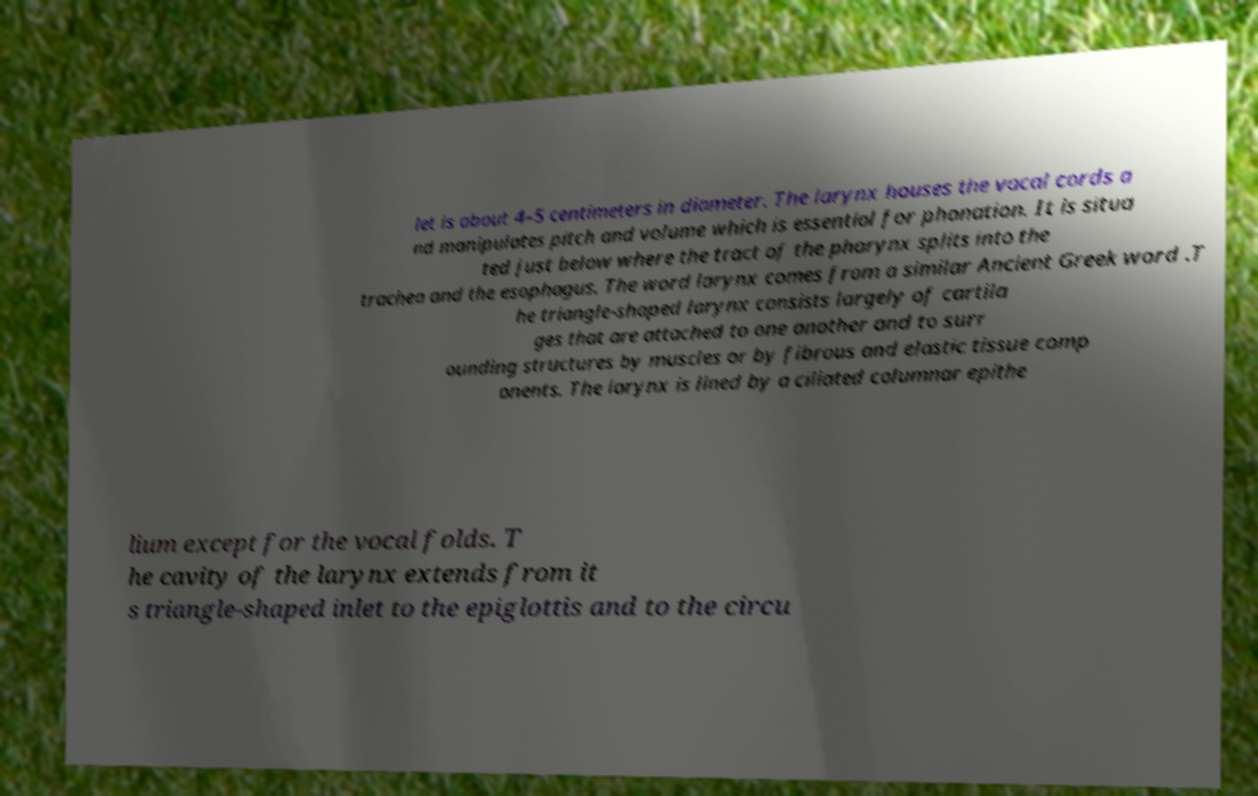Can you read and provide the text displayed in the image?This photo seems to have some interesting text. Can you extract and type it out for me? let is about 4–5 centimeters in diameter. The larynx houses the vocal cords a nd manipulates pitch and volume which is essential for phonation. It is situa ted just below where the tract of the pharynx splits into the trachea and the esophagus. The word larynx comes from a similar Ancient Greek word .T he triangle-shaped larynx consists largely of cartila ges that are attached to one another and to surr ounding structures by muscles or by fibrous and elastic tissue comp onents. The larynx is lined by a ciliated columnar epithe lium except for the vocal folds. T he cavity of the larynx extends from it s triangle-shaped inlet to the epiglottis and to the circu 